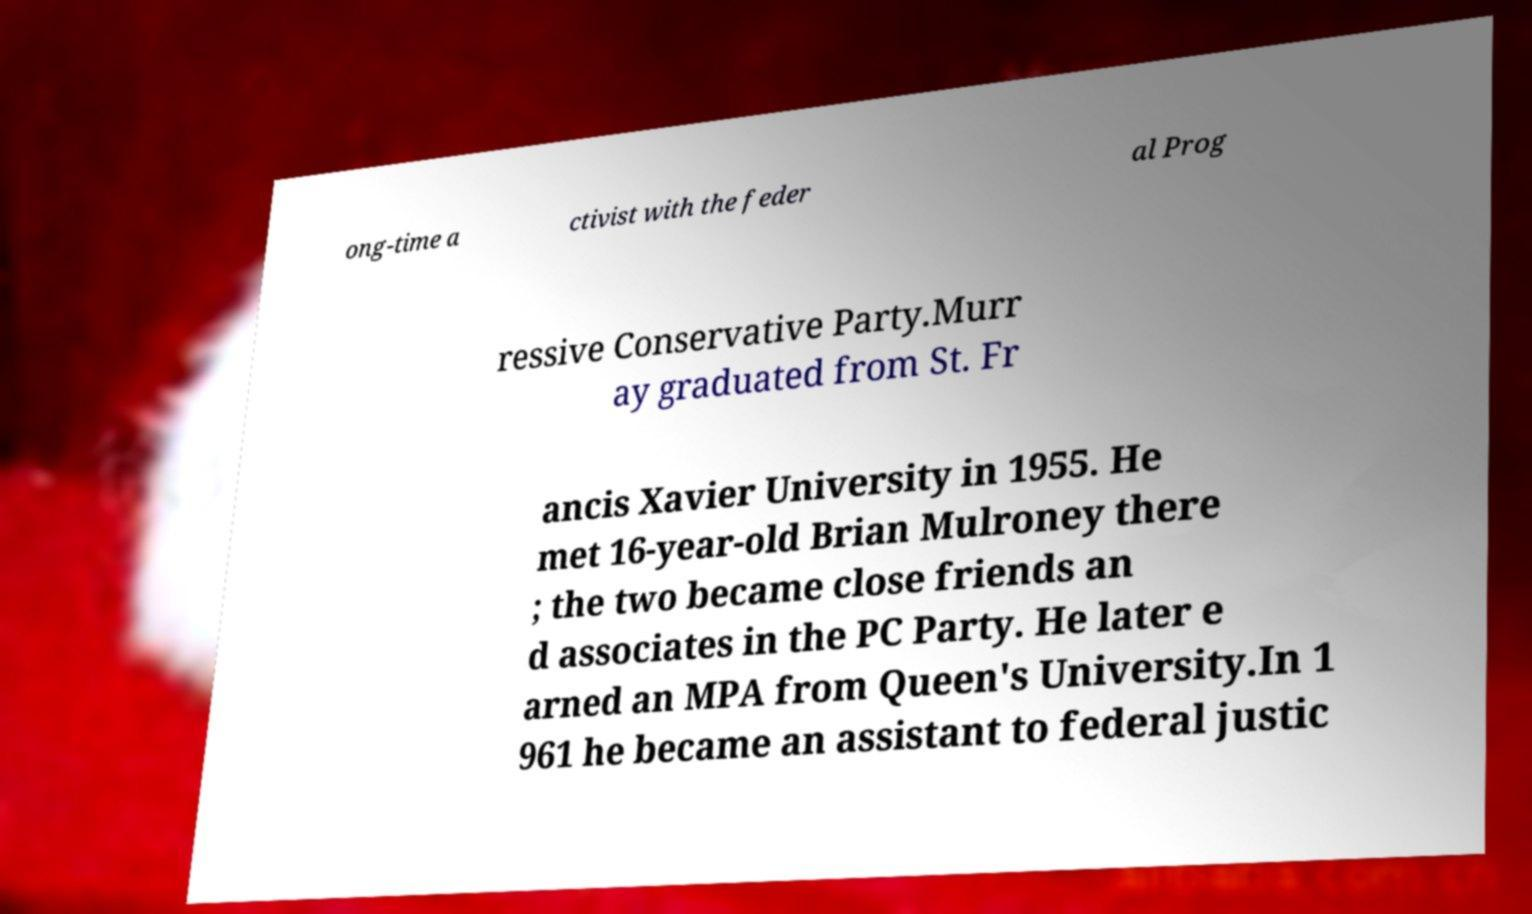Please identify and transcribe the text found in this image. ong-time a ctivist with the feder al Prog ressive Conservative Party.Murr ay graduated from St. Fr ancis Xavier University in 1955. He met 16-year-old Brian Mulroney there ; the two became close friends an d associates in the PC Party. He later e arned an MPA from Queen's University.In 1 961 he became an assistant to federal justic 